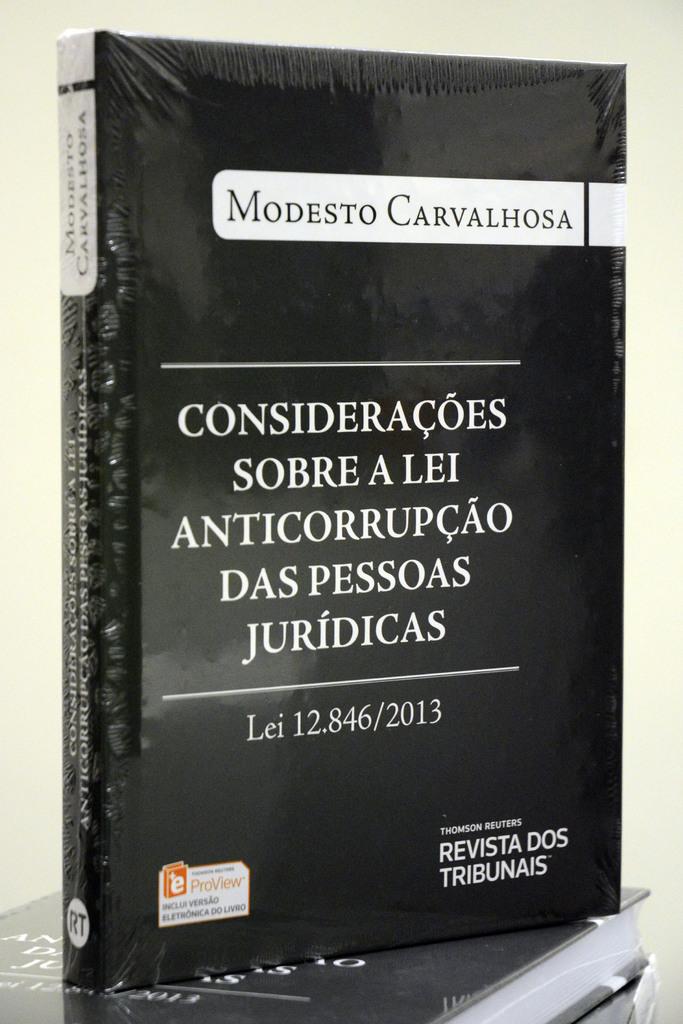Who is the author of this book?
Your answer should be very brief. Modesto carvalhosa. What numbers are next to the word lei?
Ensure brevity in your answer.  12.846/2013. 